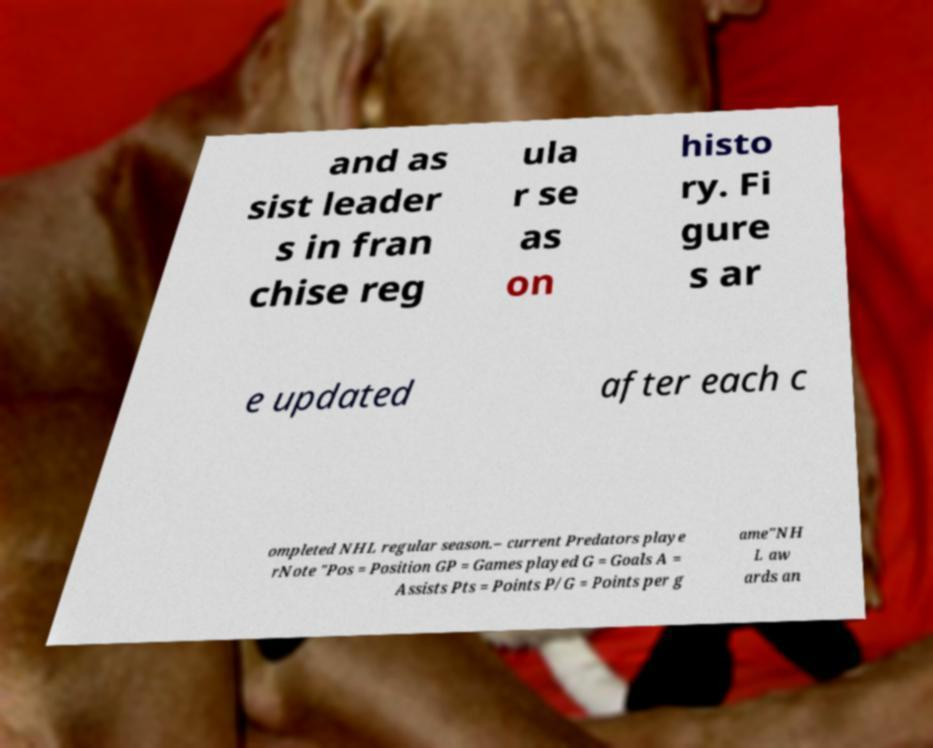I need the written content from this picture converted into text. Can you do that? and as sist leader s in fran chise reg ula r se as on histo ry. Fi gure s ar e updated after each c ompleted NHL regular season.– current Predators playe rNote "Pos = Position GP = Games played G = Goals A = Assists Pts = Points P/G = Points per g ame"NH L aw ards an 